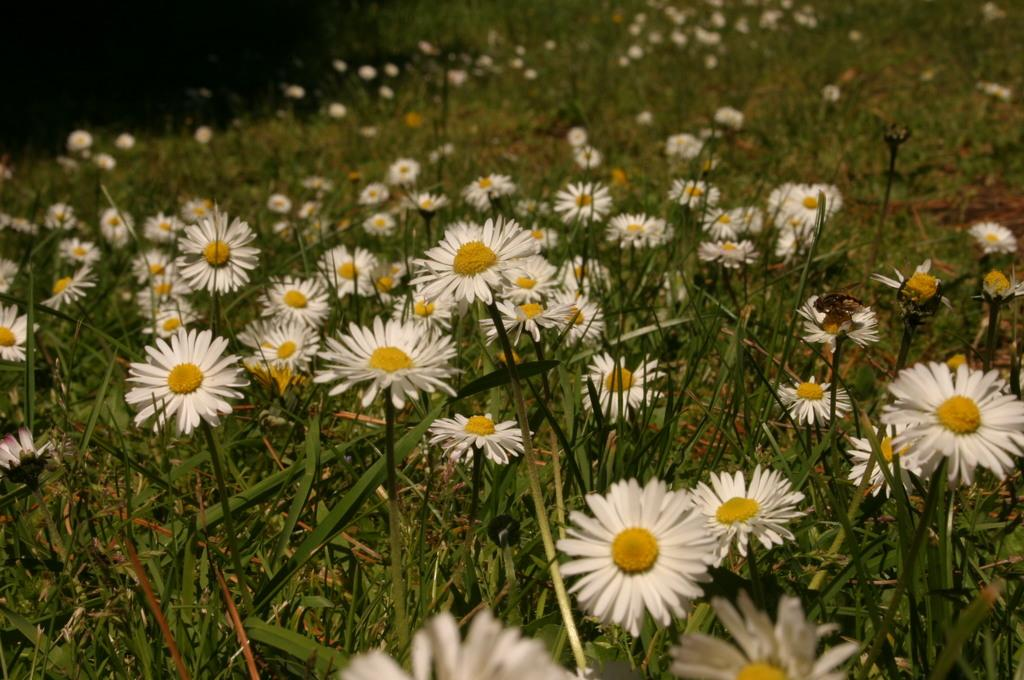What type of living organisms can be seen in the image? Plants and flowers are visible in the image. Can you describe the flowers in the image? The flowers in the image are part of the plants and add color and beauty to the scene. What type of shoe can be seen in the image? There is no shoe present in the image; it features plants and flowers. How many robins are perched on the flowers in the image? There are no robins present in the image; it only contains plants and flowers. 